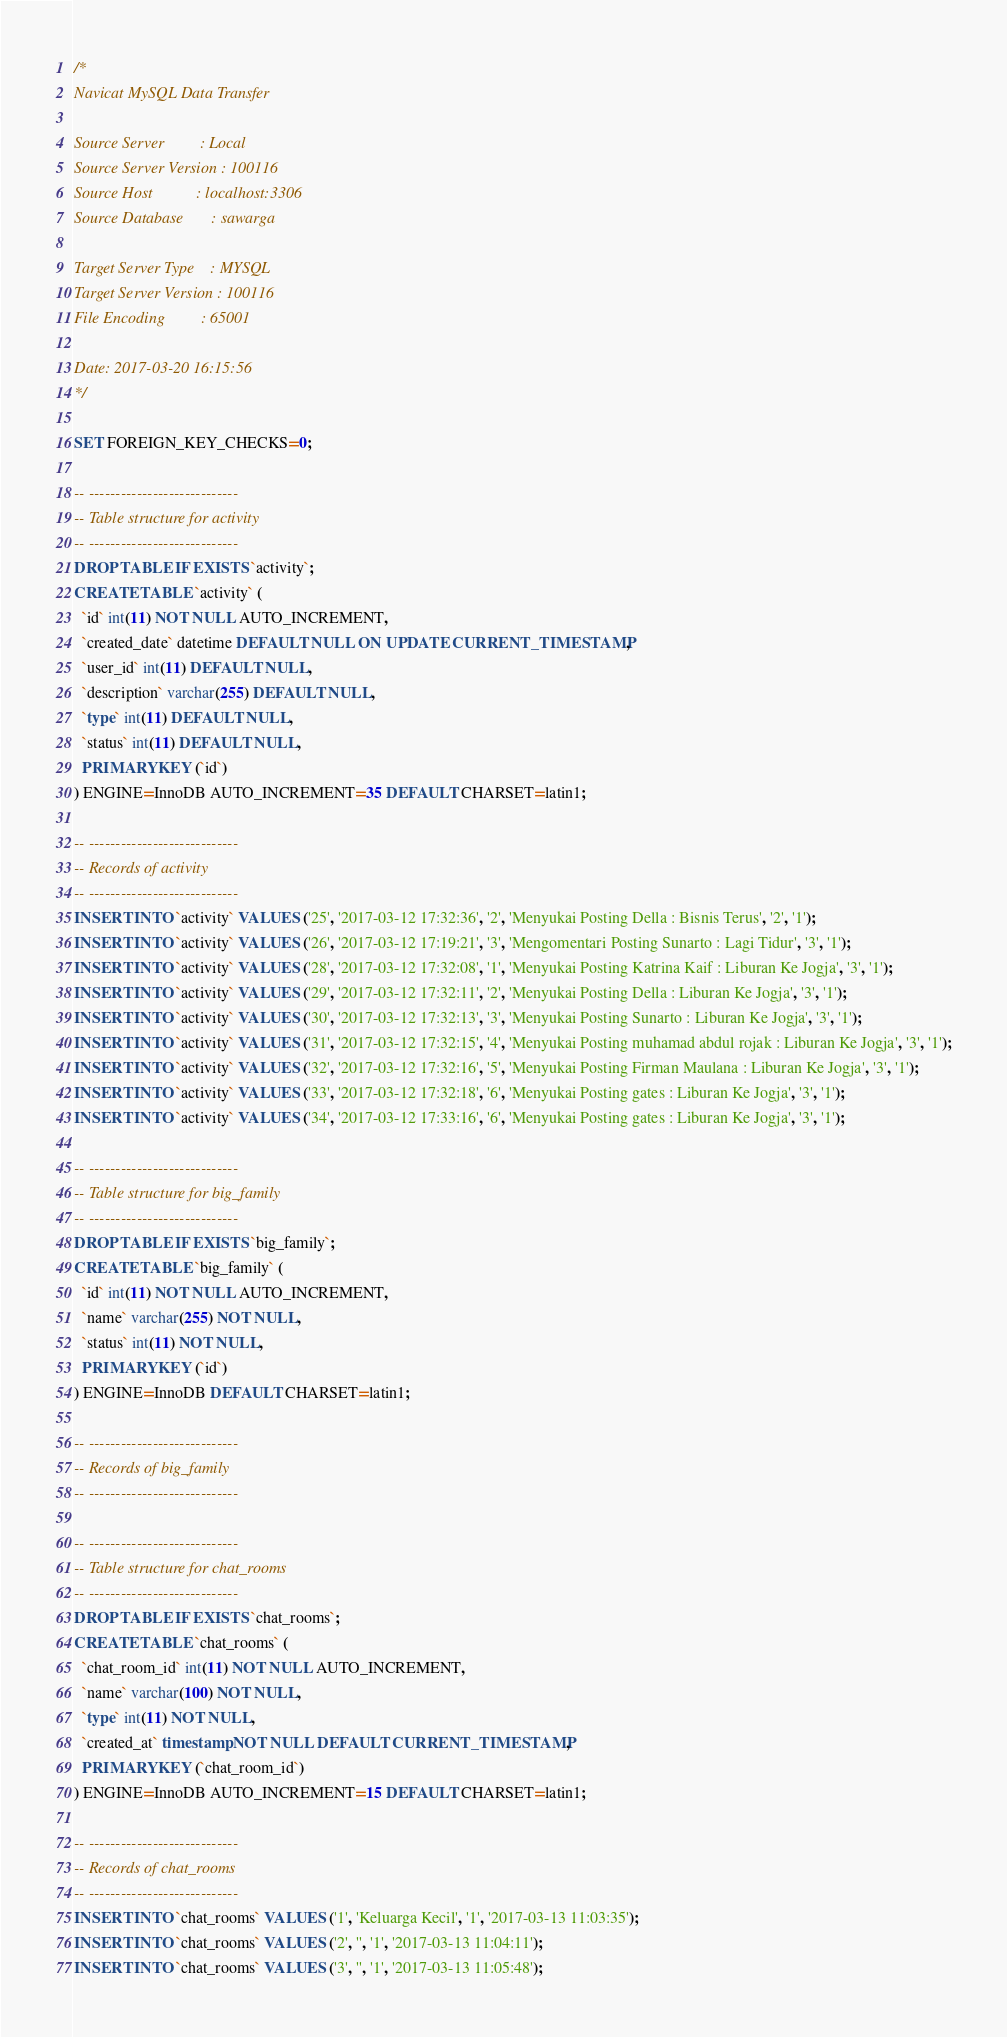<code> <loc_0><loc_0><loc_500><loc_500><_SQL_>/*
Navicat MySQL Data Transfer

Source Server         : Local
Source Server Version : 100116
Source Host           : localhost:3306
Source Database       : sawarga

Target Server Type    : MYSQL
Target Server Version : 100116
File Encoding         : 65001

Date: 2017-03-20 16:15:56
*/

SET FOREIGN_KEY_CHECKS=0;

-- ----------------------------
-- Table structure for activity
-- ----------------------------
DROP TABLE IF EXISTS `activity`;
CREATE TABLE `activity` (
  `id` int(11) NOT NULL AUTO_INCREMENT,
  `created_date` datetime DEFAULT NULL ON UPDATE CURRENT_TIMESTAMP,
  `user_id` int(11) DEFAULT NULL,
  `description` varchar(255) DEFAULT NULL,
  `type` int(11) DEFAULT NULL,
  `status` int(11) DEFAULT NULL,
  PRIMARY KEY (`id`)
) ENGINE=InnoDB AUTO_INCREMENT=35 DEFAULT CHARSET=latin1;

-- ----------------------------
-- Records of activity
-- ----------------------------
INSERT INTO `activity` VALUES ('25', '2017-03-12 17:32:36', '2', 'Menyukai Posting Della : Bisnis Terus', '2', '1');
INSERT INTO `activity` VALUES ('26', '2017-03-12 17:19:21', '3', 'Mengomentari Posting Sunarto : Lagi Tidur', '3', '1');
INSERT INTO `activity` VALUES ('28', '2017-03-12 17:32:08', '1', 'Menyukai Posting Katrina Kaif : Liburan Ke Jogja', '3', '1');
INSERT INTO `activity` VALUES ('29', '2017-03-12 17:32:11', '2', 'Menyukai Posting Della : Liburan Ke Jogja', '3', '1');
INSERT INTO `activity` VALUES ('30', '2017-03-12 17:32:13', '3', 'Menyukai Posting Sunarto : Liburan Ke Jogja', '3', '1');
INSERT INTO `activity` VALUES ('31', '2017-03-12 17:32:15', '4', 'Menyukai Posting muhamad abdul rojak : Liburan Ke Jogja', '3', '1');
INSERT INTO `activity` VALUES ('32', '2017-03-12 17:32:16', '5', 'Menyukai Posting Firman Maulana : Liburan Ke Jogja', '3', '1');
INSERT INTO `activity` VALUES ('33', '2017-03-12 17:32:18', '6', 'Menyukai Posting gates : Liburan Ke Jogja', '3', '1');
INSERT INTO `activity` VALUES ('34', '2017-03-12 17:33:16', '6', 'Menyukai Posting gates : Liburan Ke Jogja', '3', '1');

-- ----------------------------
-- Table structure for big_family
-- ----------------------------
DROP TABLE IF EXISTS `big_family`;
CREATE TABLE `big_family` (
  `id` int(11) NOT NULL AUTO_INCREMENT,
  `name` varchar(255) NOT NULL,
  `status` int(11) NOT NULL,
  PRIMARY KEY (`id`)
) ENGINE=InnoDB DEFAULT CHARSET=latin1;

-- ----------------------------
-- Records of big_family
-- ----------------------------

-- ----------------------------
-- Table structure for chat_rooms
-- ----------------------------
DROP TABLE IF EXISTS `chat_rooms`;
CREATE TABLE `chat_rooms` (
  `chat_room_id` int(11) NOT NULL AUTO_INCREMENT,
  `name` varchar(100) NOT NULL,
  `type` int(11) NOT NULL,
  `created_at` timestamp NOT NULL DEFAULT CURRENT_TIMESTAMP,
  PRIMARY KEY (`chat_room_id`)
) ENGINE=InnoDB AUTO_INCREMENT=15 DEFAULT CHARSET=latin1;

-- ----------------------------
-- Records of chat_rooms
-- ----------------------------
INSERT INTO `chat_rooms` VALUES ('1', 'Keluarga Kecil', '1', '2017-03-13 11:03:35');
INSERT INTO `chat_rooms` VALUES ('2', '', '1', '2017-03-13 11:04:11');
INSERT INTO `chat_rooms` VALUES ('3', '', '1', '2017-03-13 11:05:48');</code> 